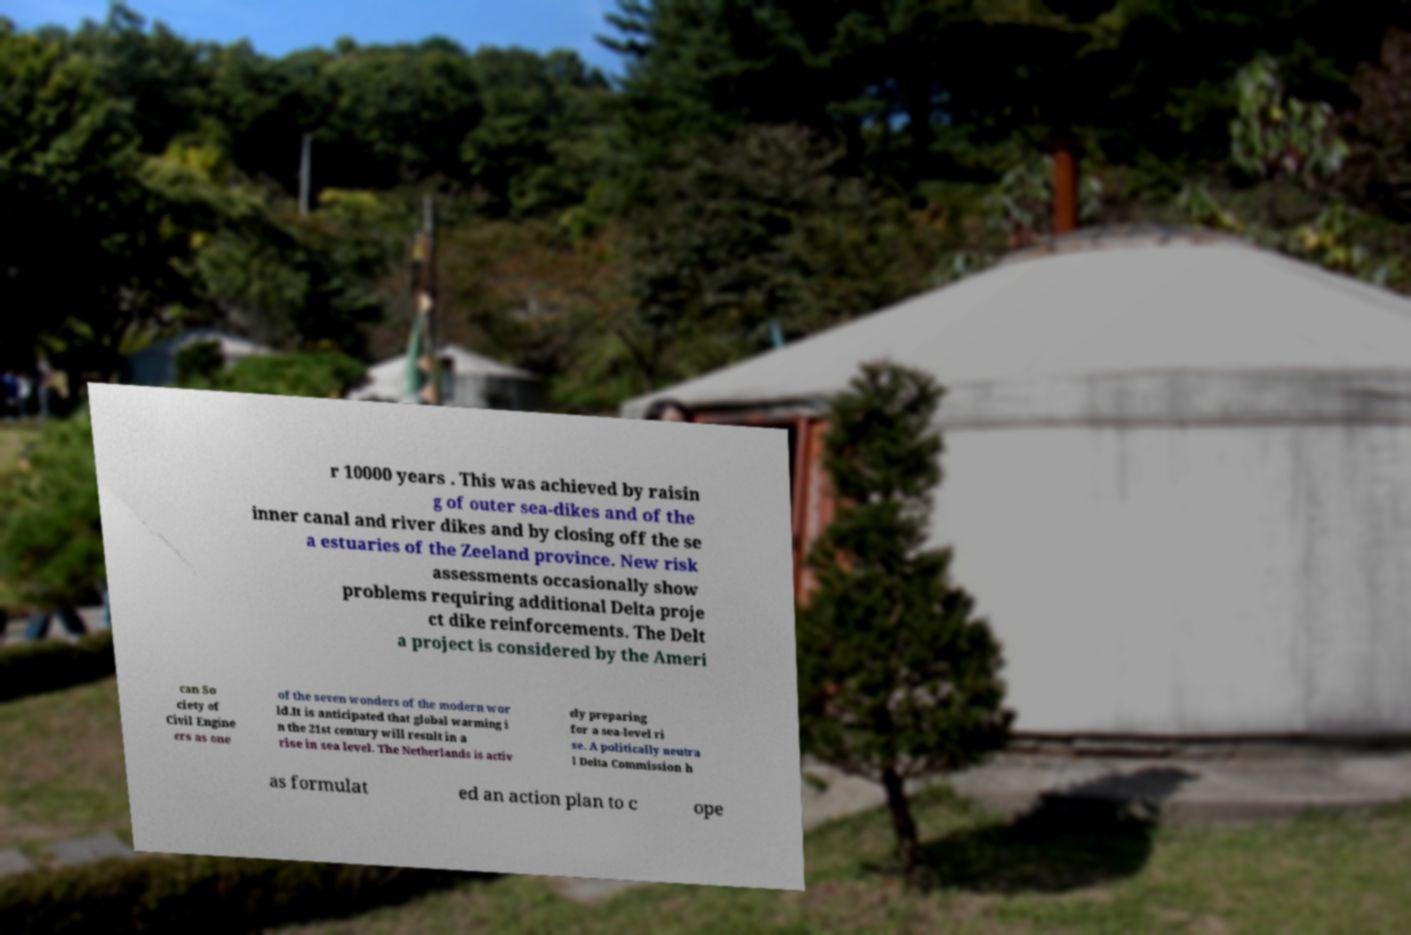Can you read and provide the text displayed in the image?This photo seems to have some interesting text. Can you extract and type it out for me? r 10000 years . This was achieved by raisin g of outer sea-dikes and of the inner canal and river dikes and by closing off the se a estuaries of the Zeeland province. New risk assessments occasionally show problems requiring additional Delta proje ct dike reinforcements. The Delt a project is considered by the Ameri can So ciety of Civil Engine ers as one of the seven wonders of the modern wor ld.It is anticipated that global warming i n the 21st century will result in a rise in sea level. The Netherlands is activ ely preparing for a sea-level ri se. A politically neutra l Delta Commission h as formulat ed an action plan to c ope 